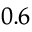<formula> <loc_0><loc_0><loc_500><loc_500>_ { 0 . 6 }</formula> 